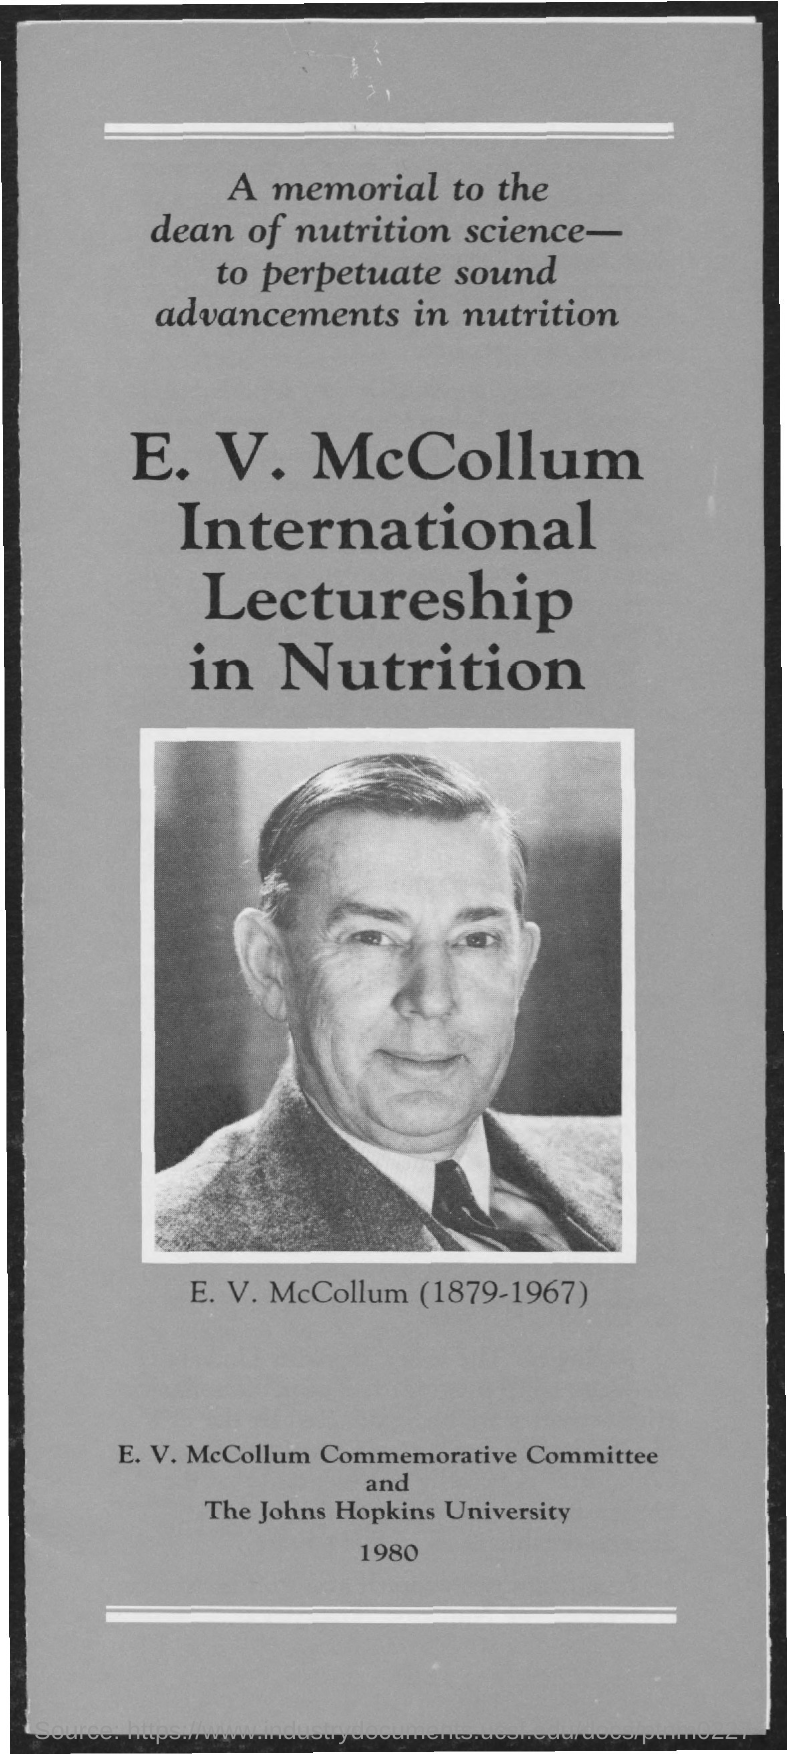What is the name of the university mentioned in the given form ?
Provide a short and direct response. The johns hopkins university. 